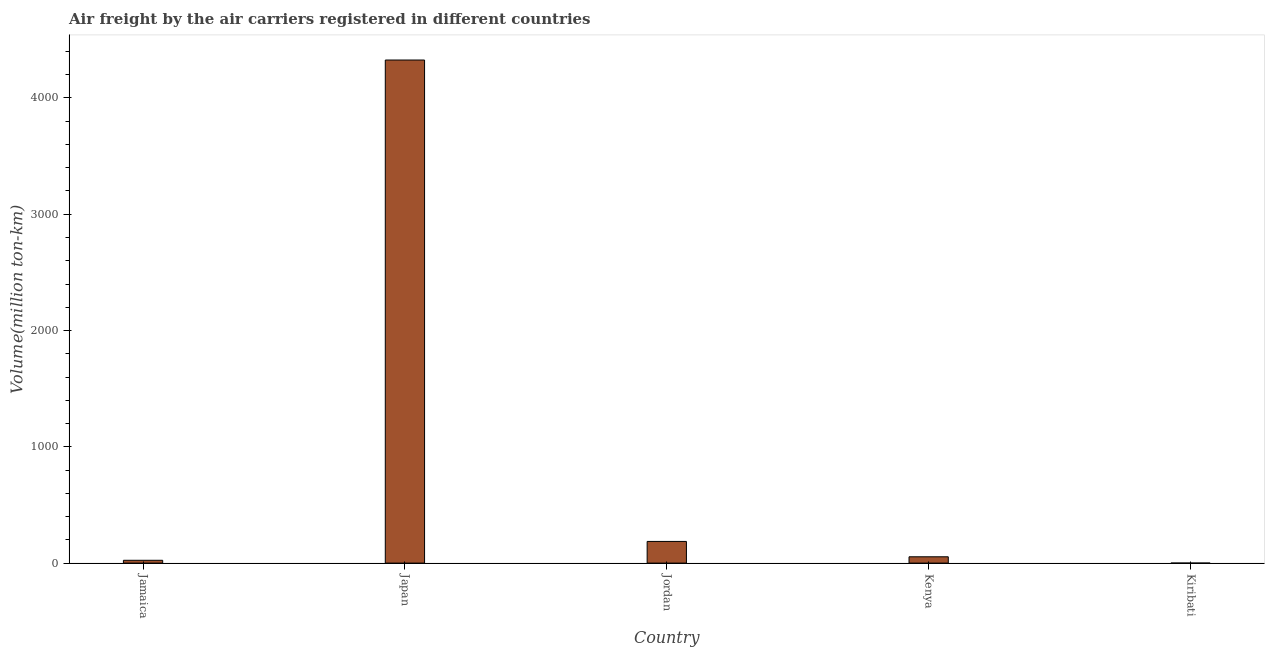Does the graph contain any zero values?
Your response must be concise. No. What is the title of the graph?
Ensure brevity in your answer.  Air freight by the air carriers registered in different countries. What is the label or title of the X-axis?
Provide a succinct answer. Country. What is the label or title of the Y-axis?
Provide a short and direct response. Volume(million ton-km). What is the air freight in Japan?
Your answer should be compact. 4326.3. Across all countries, what is the maximum air freight?
Offer a terse response. 4326.3. Across all countries, what is the minimum air freight?
Provide a short and direct response. 0.1. In which country was the air freight maximum?
Make the answer very short. Japan. In which country was the air freight minimum?
Give a very brief answer. Kiribati. What is the sum of the air freight?
Provide a short and direct response. 4591.2. What is the difference between the air freight in Jamaica and Japan?
Provide a short and direct response. -4302.1. What is the average air freight per country?
Keep it short and to the point. 918.24. What is the median air freight?
Your response must be concise. 54.3. What is the ratio of the air freight in Jamaica to that in Japan?
Your answer should be very brief. 0.01. Is the difference between the air freight in Kenya and Kiribati greater than the difference between any two countries?
Keep it short and to the point. No. What is the difference between the highest and the second highest air freight?
Keep it short and to the point. 4140. What is the difference between the highest and the lowest air freight?
Provide a succinct answer. 4326.2. How many bars are there?
Your response must be concise. 5. What is the difference between two consecutive major ticks on the Y-axis?
Offer a very short reply. 1000. What is the Volume(million ton-km) of Jamaica?
Your response must be concise. 24.2. What is the Volume(million ton-km) of Japan?
Your answer should be compact. 4326.3. What is the Volume(million ton-km) of Jordan?
Your response must be concise. 186.3. What is the Volume(million ton-km) of Kenya?
Offer a terse response. 54.3. What is the Volume(million ton-km) of Kiribati?
Your answer should be compact. 0.1. What is the difference between the Volume(million ton-km) in Jamaica and Japan?
Make the answer very short. -4302.1. What is the difference between the Volume(million ton-km) in Jamaica and Jordan?
Ensure brevity in your answer.  -162.1. What is the difference between the Volume(million ton-km) in Jamaica and Kenya?
Your answer should be very brief. -30.1. What is the difference between the Volume(million ton-km) in Jamaica and Kiribati?
Make the answer very short. 24.1. What is the difference between the Volume(million ton-km) in Japan and Jordan?
Keep it short and to the point. 4140. What is the difference between the Volume(million ton-km) in Japan and Kenya?
Keep it short and to the point. 4272. What is the difference between the Volume(million ton-km) in Japan and Kiribati?
Your answer should be compact. 4326.2. What is the difference between the Volume(million ton-km) in Jordan and Kenya?
Provide a succinct answer. 132. What is the difference between the Volume(million ton-km) in Jordan and Kiribati?
Provide a succinct answer. 186.2. What is the difference between the Volume(million ton-km) in Kenya and Kiribati?
Provide a short and direct response. 54.2. What is the ratio of the Volume(million ton-km) in Jamaica to that in Japan?
Provide a succinct answer. 0.01. What is the ratio of the Volume(million ton-km) in Jamaica to that in Jordan?
Offer a very short reply. 0.13. What is the ratio of the Volume(million ton-km) in Jamaica to that in Kenya?
Offer a terse response. 0.45. What is the ratio of the Volume(million ton-km) in Jamaica to that in Kiribati?
Offer a very short reply. 242. What is the ratio of the Volume(million ton-km) in Japan to that in Jordan?
Provide a short and direct response. 23.22. What is the ratio of the Volume(million ton-km) in Japan to that in Kenya?
Offer a terse response. 79.67. What is the ratio of the Volume(million ton-km) in Japan to that in Kiribati?
Make the answer very short. 4.33e+04. What is the ratio of the Volume(million ton-km) in Jordan to that in Kenya?
Provide a short and direct response. 3.43. What is the ratio of the Volume(million ton-km) in Jordan to that in Kiribati?
Provide a succinct answer. 1863. What is the ratio of the Volume(million ton-km) in Kenya to that in Kiribati?
Keep it short and to the point. 543. 